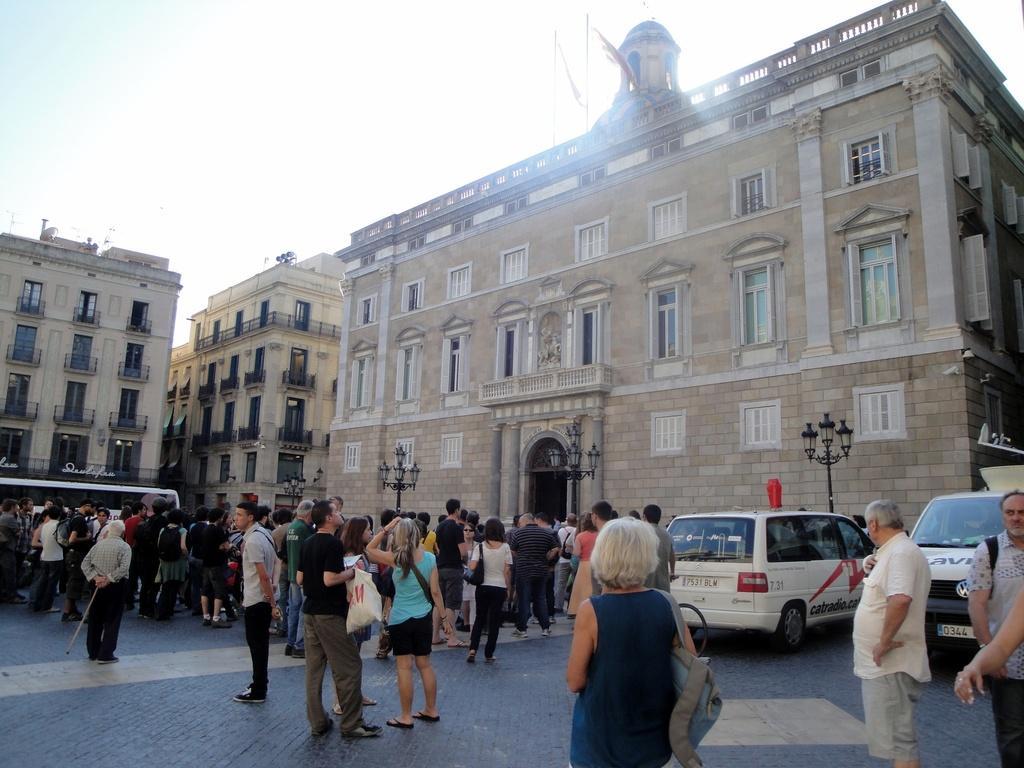How would you summarize this image in a sentence or two? This picture is clicked outside the city. In this picture, we see many people are standing on the road. On the right side, we see two cars which are parked on the road. Beside that, there are light poles. There are buildings in the background. At the top of the picture, we see the sky. 